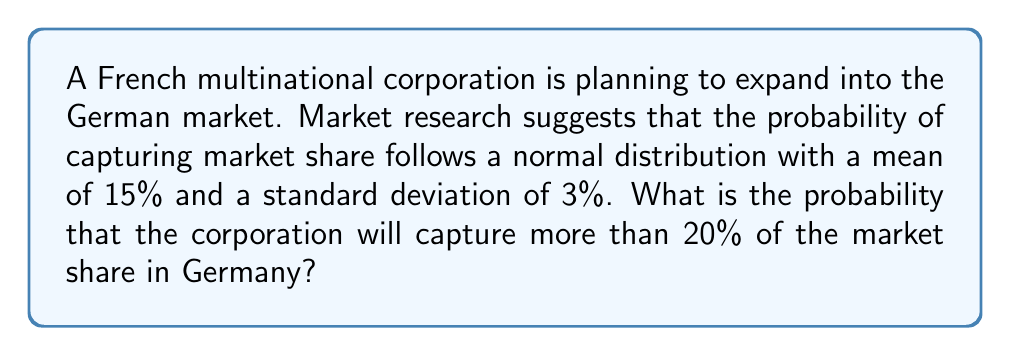Could you help me with this problem? To solve this problem, we need to use the properties of the normal distribution and the concept of z-scores.

Step 1: Identify the given information
- The market share follows a normal distribution
- Mean (μ) = 15%
- Standard deviation (σ) = 3%
- We want to find P(X > 20%), where X is the market share

Step 2: Calculate the z-score for 20% market share
The z-score formula is: $z = \frac{x - μ}{σ}$

Plugging in the values:
$z = \frac{20 - 15}{3} = \frac{5}{3} ≈ 1.67$

Step 3: Use the standard normal distribution table or calculator
We need to find P(Z > 1.67), where Z is the standard normal variable.

Using the standard normal table or a calculator, we find:
P(Z > 1.67) ≈ 0.0475

Step 4: Interpret the result
The probability of capturing more than 20% of the market share is approximately 0.0475 or 4.75%.
Answer: 0.0475 (or 4.75%) 